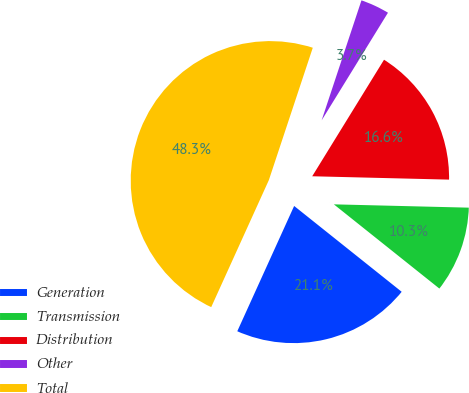Convert chart. <chart><loc_0><loc_0><loc_500><loc_500><pie_chart><fcel>Generation<fcel>Transmission<fcel>Distribution<fcel>Other<fcel>Total<nl><fcel>21.06%<fcel>10.33%<fcel>16.6%<fcel>3.69%<fcel>48.32%<nl></chart> 